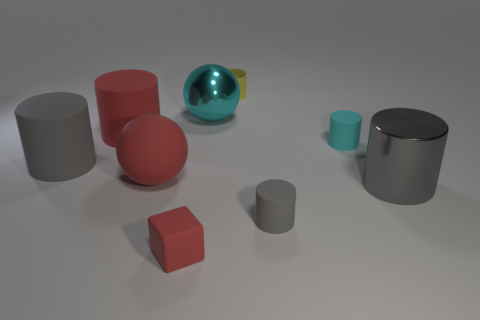The big matte thing that is the same color as the large metal cylinder is what shape?
Offer a terse response. Cylinder. There is a cyan object that is the same material as the red block; what is its size?
Keep it short and to the point. Small. What number of large cyan spheres are on the right side of the large gray cylinder on the left side of the rubber ball?
Offer a very short reply. 1. Are there any other yellow things that have the same shape as the small shiny object?
Your answer should be compact. No. There is a small rubber thing in front of the small gray rubber cylinder in front of the large gray metal object; what color is it?
Offer a very short reply. Red. Are there more big metal things than small green matte cubes?
Your answer should be compact. Yes. What number of cyan cylinders have the same size as the cyan sphere?
Make the answer very short. 0. Is the block made of the same material as the large gray cylinder left of the tiny gray rubber cylinder?
Provide a short and direct response. Yes. Are there fewer large red cylinders than green cubes?
Make the answer very short. No. Are there any other things of the same color as the small shiny object?
Ensure brevity in your answer.  No. 